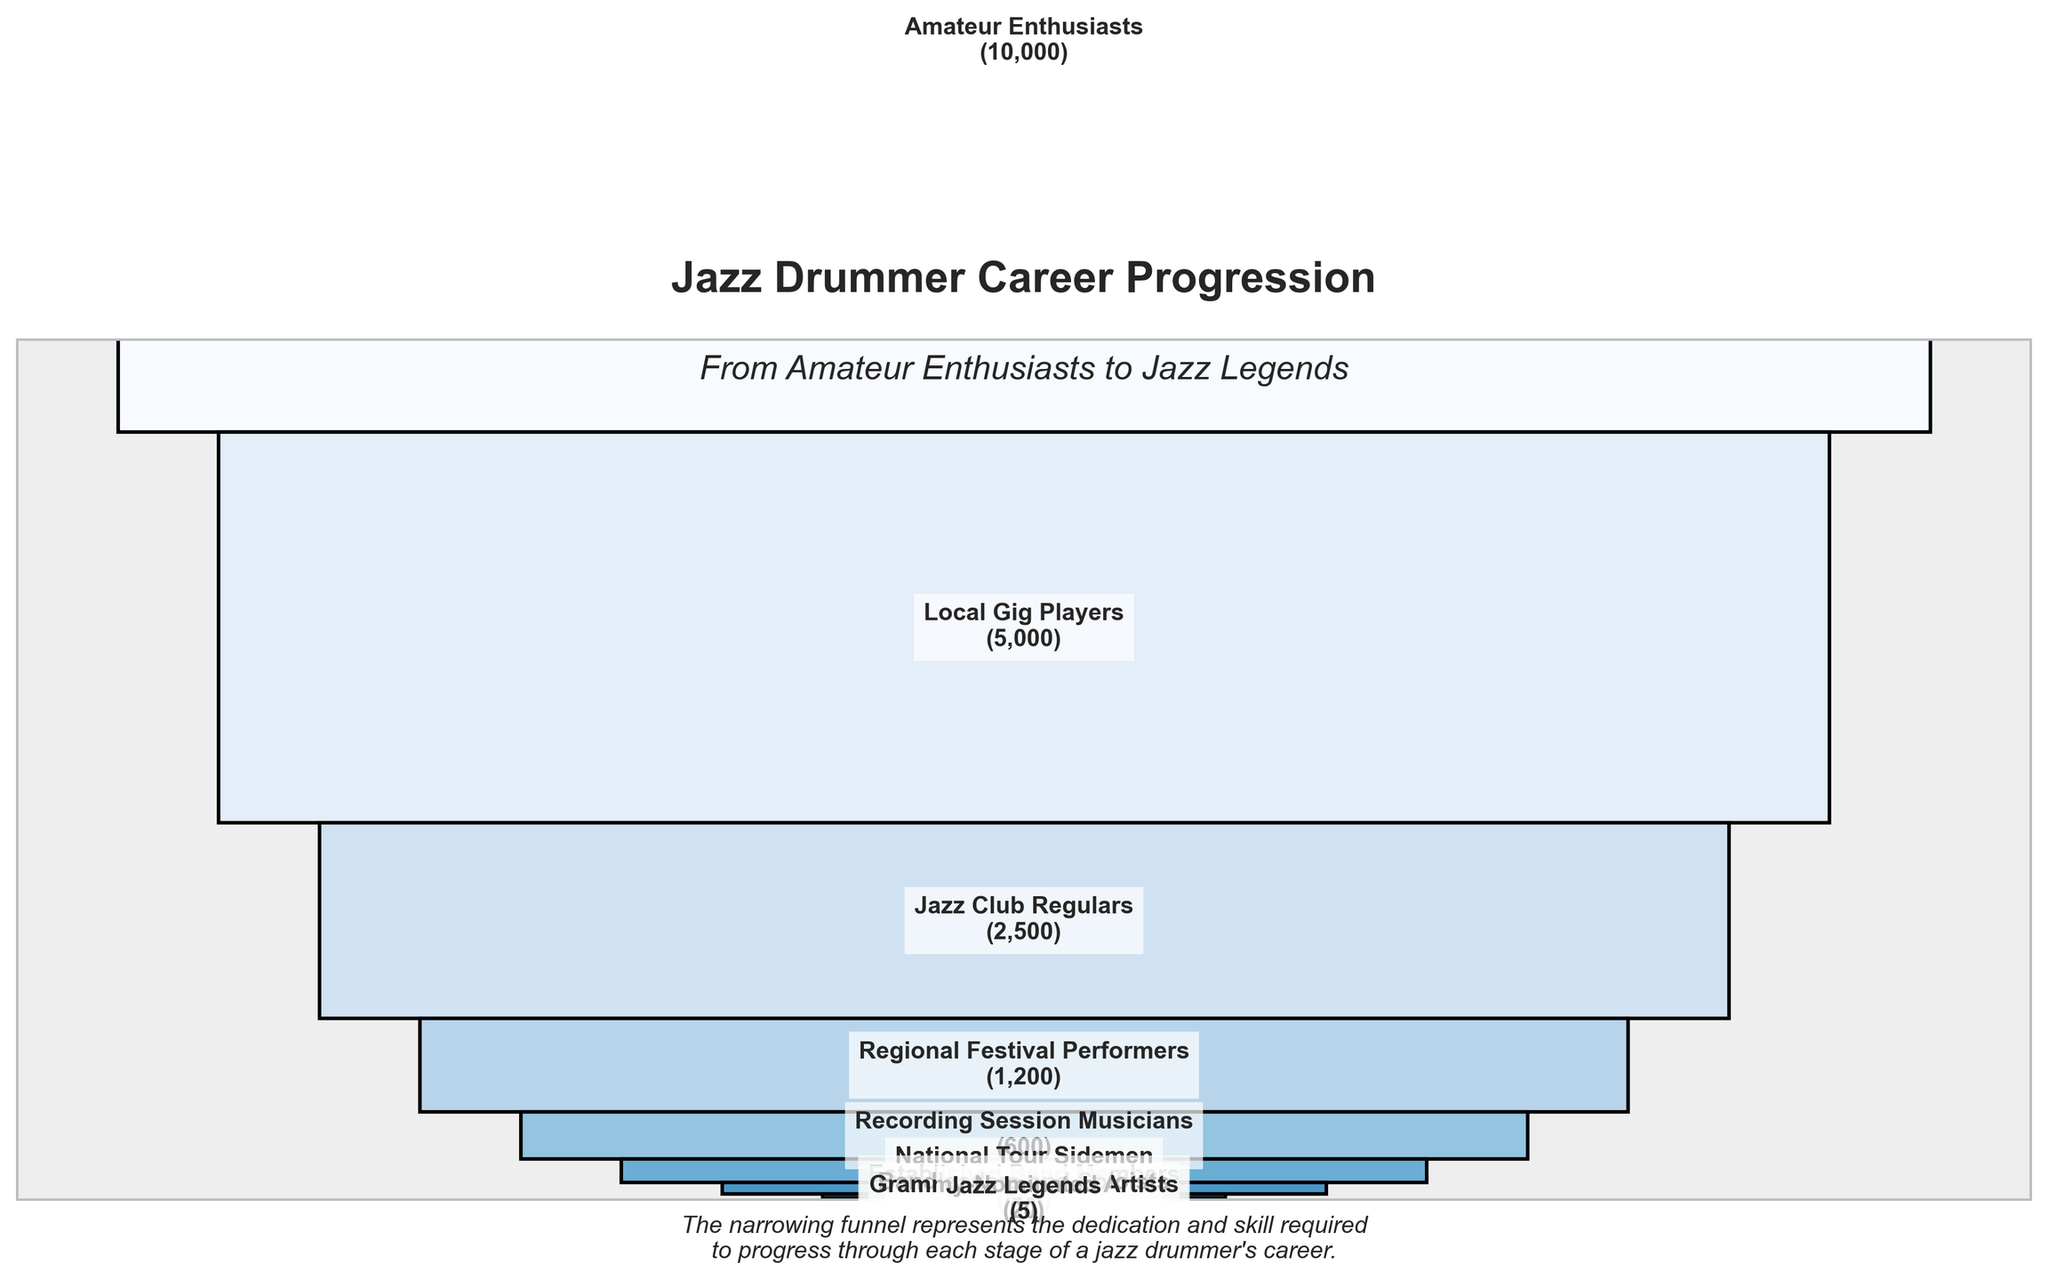What is the title of the funnel chart? The title of the funnel chart is displayed prominently at the top of the figure. It states "Jazz Drummer Career Progression".
Answer: Jazz Drummer Career Progression Which stage has the fewest number of drummers? The stage with the fewest number of drummers is visually represented by the smallest bar at the bottom of the funnel chart. This stage is labeled "Jazz Legends" and shows 5 drummers.
Answer: Jazz Legends How many stages are there in this career progression funnel? To find the number of stages, count the number of labeled segments in the funnel. The figure has 10 stages listed from top to bottom.
Answer: 10 What is the difference in the number of drummers between "Local Gig Players" and "National Tour Sidemen"? To find the difference, note the numbers for "Local Gig Players" (5000) and "National Tour Sidemen" (300). Subtract the smaller number from the larger number: 5000 - 300 = 4700.
Answer: 4700 What percentage of "Amateur Enthusiasts" advance to "Regional Festival Performers"? First, find the numbers for both stages: "Amateur Enthusiasts" (10000) and "Regional Festival Performers" (1200). Calculate the percentage by dividing the number at the lower stage by the number at the higher stage and multiply by 100: (1200 / 10000) * 100 = 12%.
Answer: 12% Which group has more drummers, "Recording Session Musicians" or "Jazz Club Regulars"? Compare the figures for both stages: "Recording Session Musicians" has 600 drummers while "Jazz Club Regulars" has 2500 drummers. "Jazz Club Regulars" has more drummers.
Answer: Jazz Club Regulars How many drummers total are in the last three stages combined? Add the number of drummers in the last three stages: "Bandleaders and Soloists" (50), "Grammy-Nominated Artists" (20), and "Jazz Legends" (5). Sum them up: 50 + 20 + 5 = 75.
Answer: 75 What is the average number of drummers from "Local Gig Players" to "National Tour Sidemen"? The stages to consider are: "Local Gig Players" (5000), "Jazz Club Regulars" (2500), "Regional Festival Performers" (1200), "Recording Session Musicians" (600), and "National Tour Sidemen" (300). Sum them up and divide by the number of stages: (5000 + 2500 + 1200 + 600 + 300) / 5 = 1920.
Answer: 1920 What is visually represented at the center of each bar segment? In the center of each bar segment, there are labels that show the stage name along with the number of drummers in that stage, formatted as "Stage (Number of Drummers)".
Answer: Stage name and number of drummers In which stage do the numbers of drummers halve compared to the previous stage? Compare each stage to its previous one: "Amateur Enthusiasts" (10000), "Local Gig Players" (5000), "Jazz Club Regulars" (2500), and "Regional Festival Performers" (1200). Between "Jazz Club Regulars" and "Regional Festival Performers", the number approximately halves from 2500 to 1200.
Answer: From "Jazz Club Regulars" to "Regional Festival Performers" 